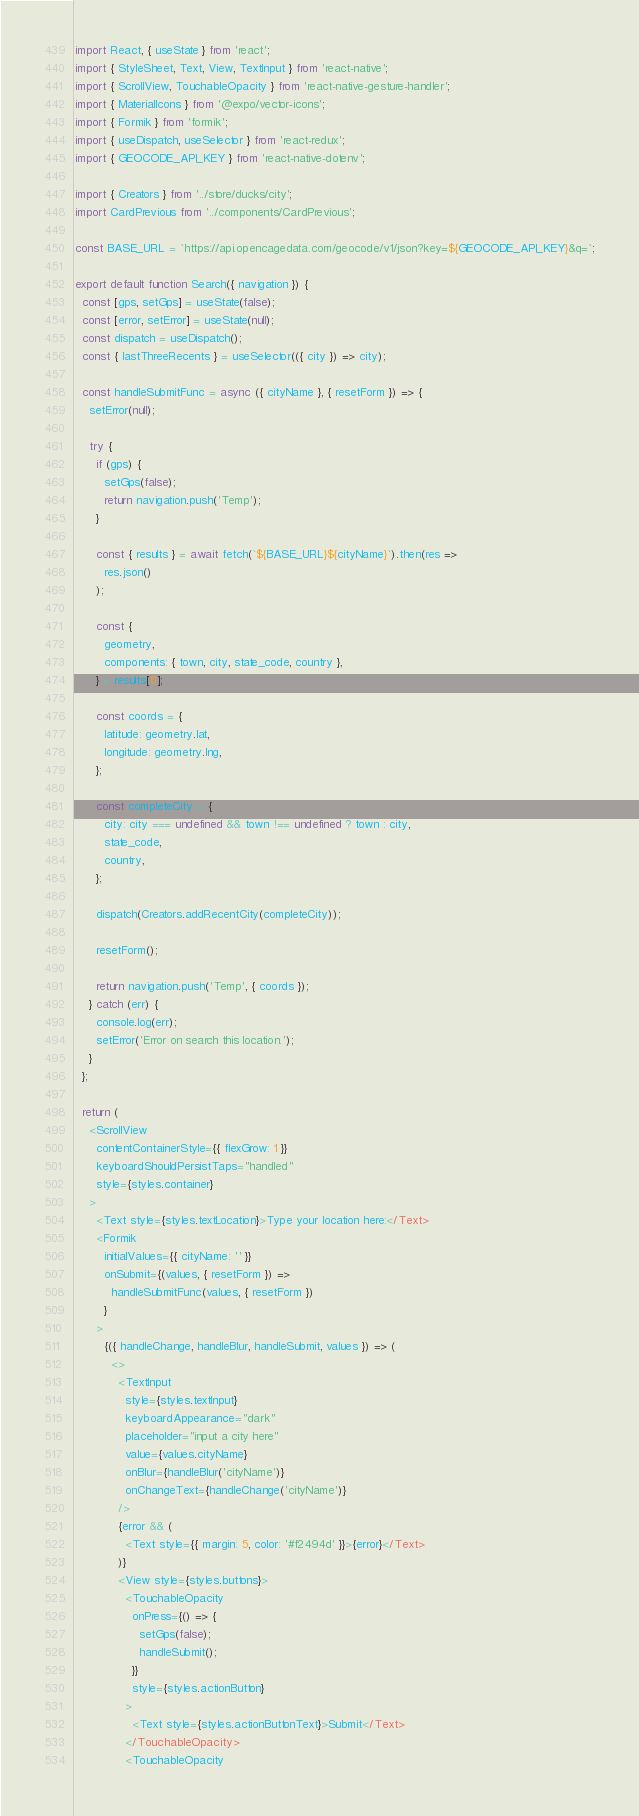Convert code to text. <code><loc_0><loc_0><loc_500><loc_500><_JavaScript_>import React, { useState } from 'react';
import { StyleSheet, Text, View, TextInput } from 'react-native';
import { ScrollView, TouchableOpacity } from 'react-native-gesture-handler';
import { MaterialIcons } from '@expo/vector-icons';
import { Formik } from 'formik';
import { useDispatch, useSelector } from 'react-redux';
import { GEOCODE_API_KEY } from 'react-native-dotenv';

import { Creators } from '../store/ducks/city';
import CardPrevious from '../components/CardPrevious';

const BASE_URL = `https://api.opencagedata.com/geocode/v1/json?key=${GEOCODE_API_KEY}&q=`;

export default function Search({ navigation }) {
  const [gps, setGps] = useState(false);
  const [error, setError] = useState(null);
  const dispatch = useDispatch();
  const { lastThreeRecents } = useSelector(({ city }) => city);

  const handleSubmitFunc = async ({ cityName }, { resetForm }) => {
    setError(null);

    try {
      if (gps) {
        setGps(false);
        return navigation.push('Temp');
      }

      const { results } = await fetch(`${BASE_URL}${cityName}`).then(res =>
        res.json()
      );

      const {
        geometry,
        components: { town, city, state_code, country },
      } = results[0];

      const coords = {
        latitude: geometry.lat,
        longitude: geometry.lng,
      };

      const completeCity = {
        city: city === undefined && town !== undefined ? town : city,
        state_code,
        country,
      };

      dispatch(Creators.addRecentCity(completeCity));

      resetForm();

      return navigation.push('Temp', { coords });
    } catch (err) {
      console.log(err);
      setError('Error on search this location.');
    }
  };

  return (
    <ScrollView
      contentContainerStyle={{ flexGrow: 1 }}
      keyboardShouldPersistTaps="handled"
      style={styles.container}
    >
      <Text style={styles.textLocation}>Type your location here:</Text>
      <Formik
        initialValues={{ cityName: '' }}
        onSubmit={(values, { resetForm }) =>
          handleSubmitFunc(values, { resetForm })
        }
      >
        {({ handleChange, handleBlur, handleSubmit, values }) => (
          <>
            <TextInput
              style={styles.textInput}
              keyboardAppearance="dark"
              placeholder="input a city here"
              value={values.cityName}
              onBlur={handleBlur('cityName')}
              onChangeText={handleChange('cityName')}
            />
            {error && (
              <Text style={{ margin: 5, color: '#f2494d' }}>{error}</Text>
            )}
            <View style={styles.buttons}>
              <TouchableOpacity
                onPress={() => {
                  setGps(false);
                  handleSubmit();
                }}
                style={styles.actionButton}
              >
                <Text style={styles.actionButtonText}>Submit</Text>
              </TouchableOpacity>
              <TouchableOpacity</code> 